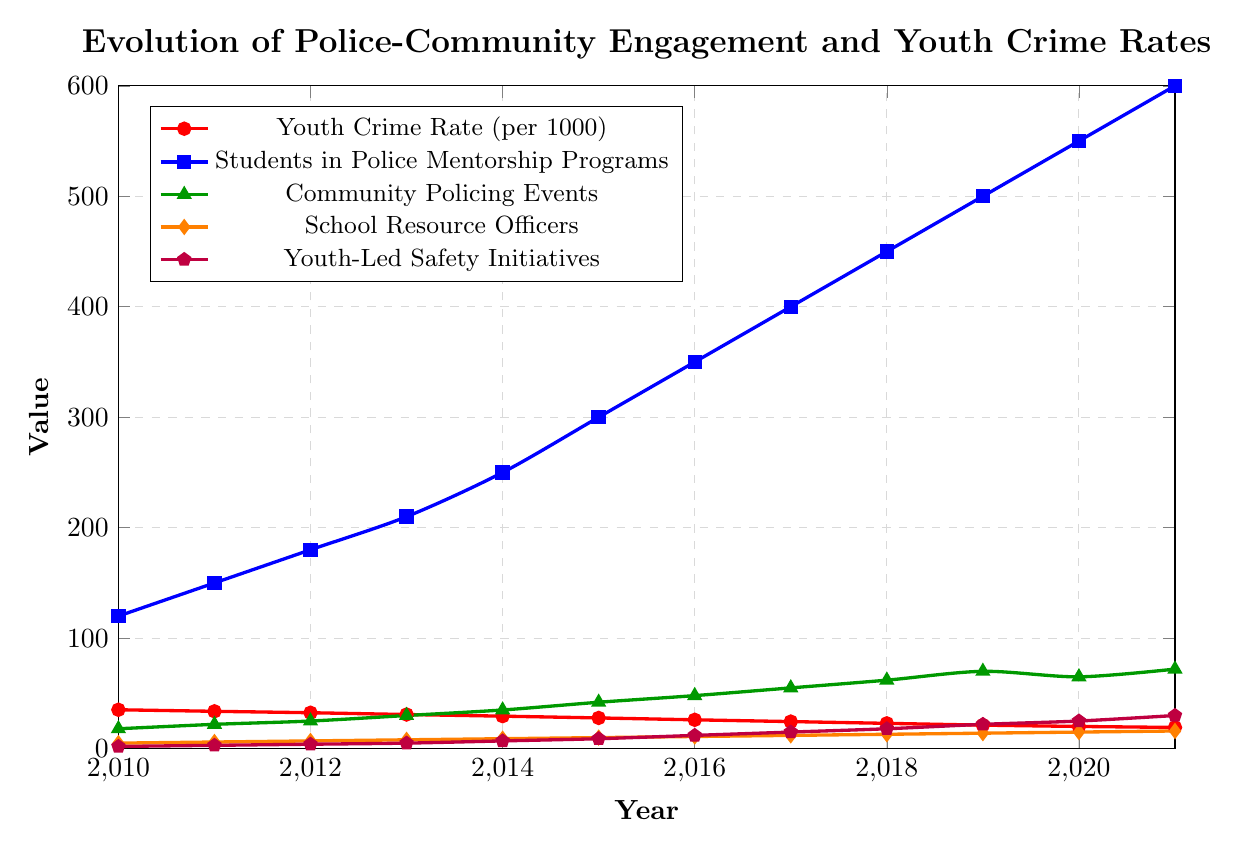What is the overall trend in youth crime rates from 2010 to 2021? The youth crime rate decreases consistently from 35.2 per 1000 in 2010 to 19.2 per 1000 in 2021. This indicates a downward trend in youth crime rates over the years.
Answer: Downward trend Which program witnessed the highest increase from 2010 to 2021? The Students in Police Mentorship Programs increased from 120 to 600, which is the highest increase among all the programs. To observe this, we can compare the starting and ending values of each program.
Answer: Students in Police Mentorship Programs In which year did the number of Community Policing Events surpass 50? The number of Community Policing Events surpassed 50 in 2017, as it reached 55 that year. Refer to the data points for the green line representing Community Policing Events.
Answer: 2017 By how much did the youth crime rate decrease between 2015 and 2019? The youth crime rate decreased from 27.8 in 2015 to 21.3 in 2019. The difference can be calculated as 27.8 - 21.3 = 6.5.
Answer: 6.5 Which data series shows an increasing trend but had a slight drop in 2020? The Community Policing Events show an increasing trend with a slight drop in 2020, falling from 70 in 2019 to 65 in 2020, before rising again in 2021.
Answer: Community Policing Events What is the relationship between the number of School Resource Officers and the Youth Crime Rate over the years? As the number of School Resource Officers increases from 5 in 2010 to 16 in 2021, the Youth Crime Rate consistently decreases from 35.2 to 19.2 in the same period. This suggests an inverse relationship.
Answer: Inverse relationship Compare the increase in Youth-Led Safety Initiatives in 2015 and 2021. Youth-Led Safety Initiatives increased from 9 in 2015 to 30 in 2021. The difference is 30 - 9 = 21.
Answer: 21 What was the value of Students in Police Mentorship Programs in 2013? In 2013, the number of students in Police Mentorship Programs was 210. Refer to the blue line at the year 2013.
Answer: 210 Between 2017 and 2020, which metric experienced the greatest change? Students in Police Mentorship Programs experienced the greatest change, increasing from 400 in 2017 to 550 in 2020. The change can be calculated as 550 - 400 = 150.
Answer: Students in Police Mentorship Programs How many more Youth-Led Safety Initiatives were there in 2021 compared to 2010? In 2010, there were 2 Youth-Led Safety Initiatives, whereas in 2021, there were 30. The increase is 30 - 2 = 28 initiatives.
Answer: 28 